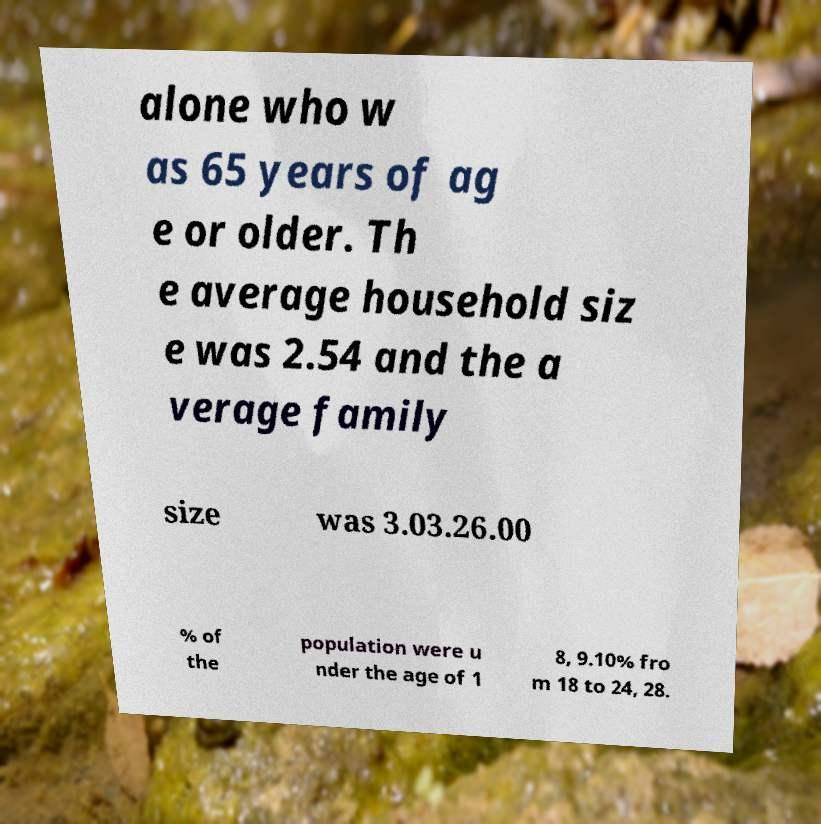Please identify and transcribe the text found in this image. alone who w as 65 years of ag e or older. Th e average household siz e was 2.54 and the a verage family size was 3.03.26.00 % of the population were u nder the age of 1 8, 9.10% fro m 18 to 24, 28. 